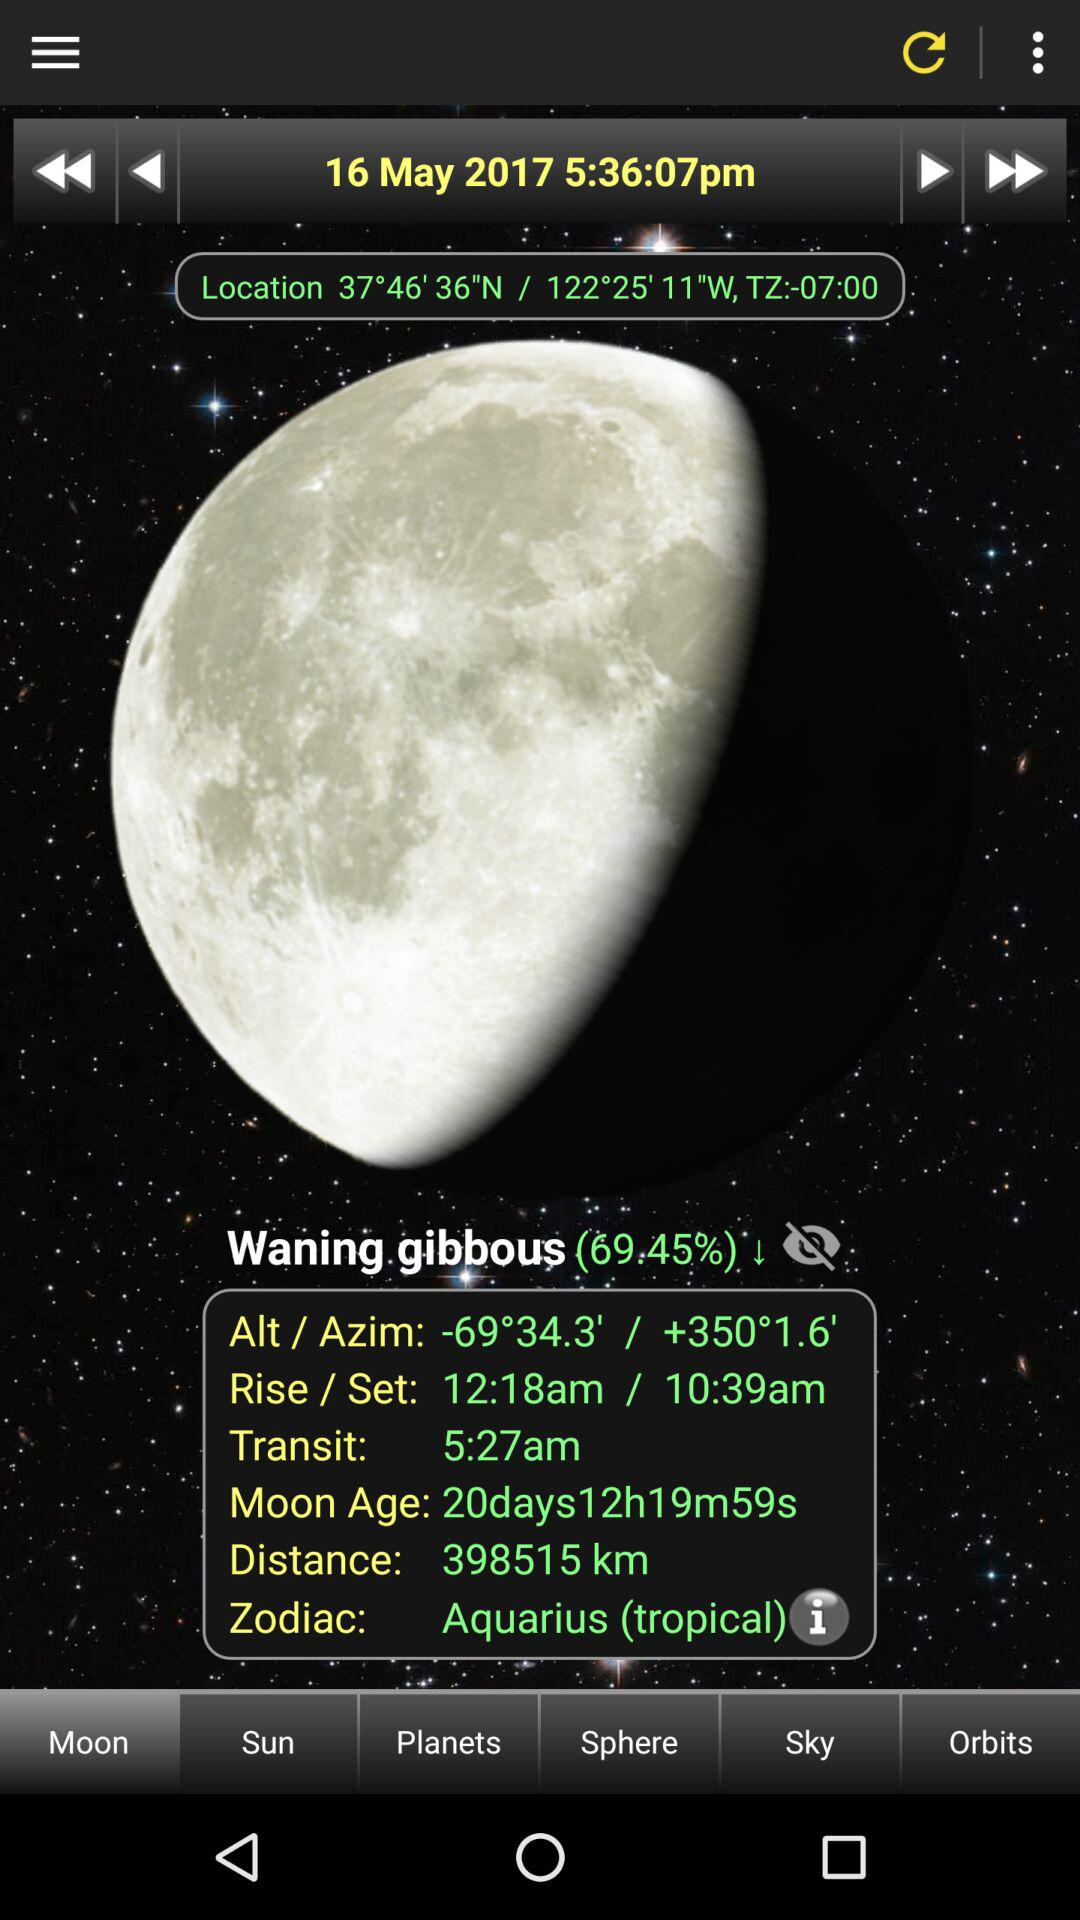Which tab is selected? The selected tab is "Moon". 